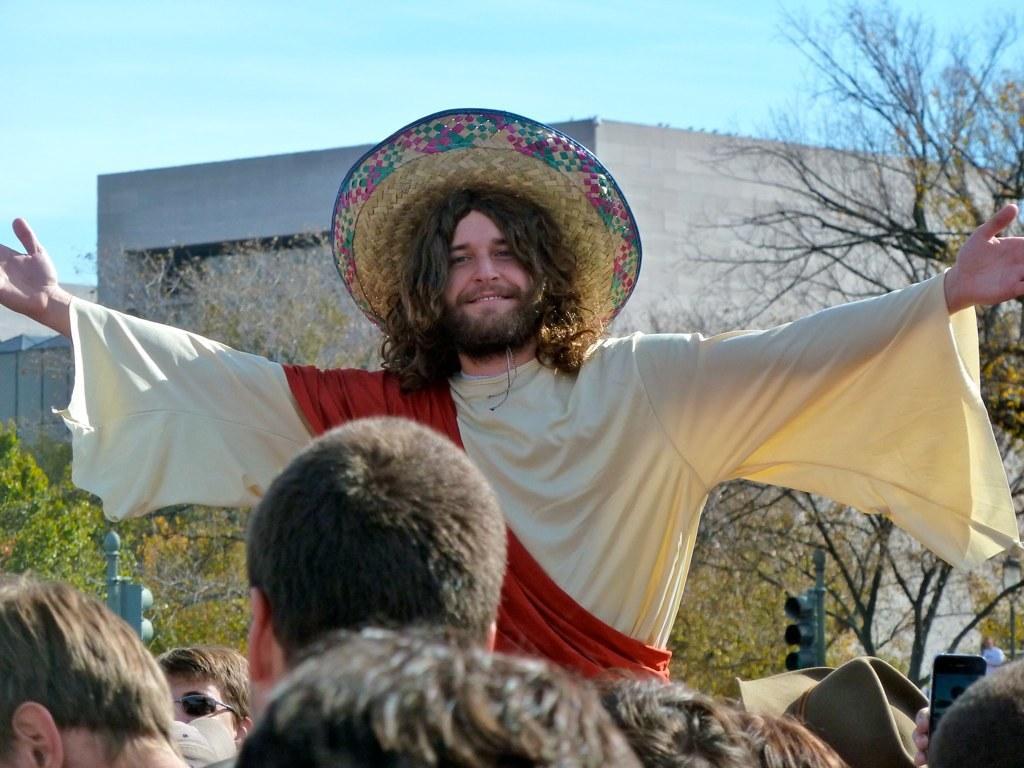Describe this image in one or two sentences. In this image we can see a few people there are some trees, buildings, lights and poles, in the background we can see the sky. 